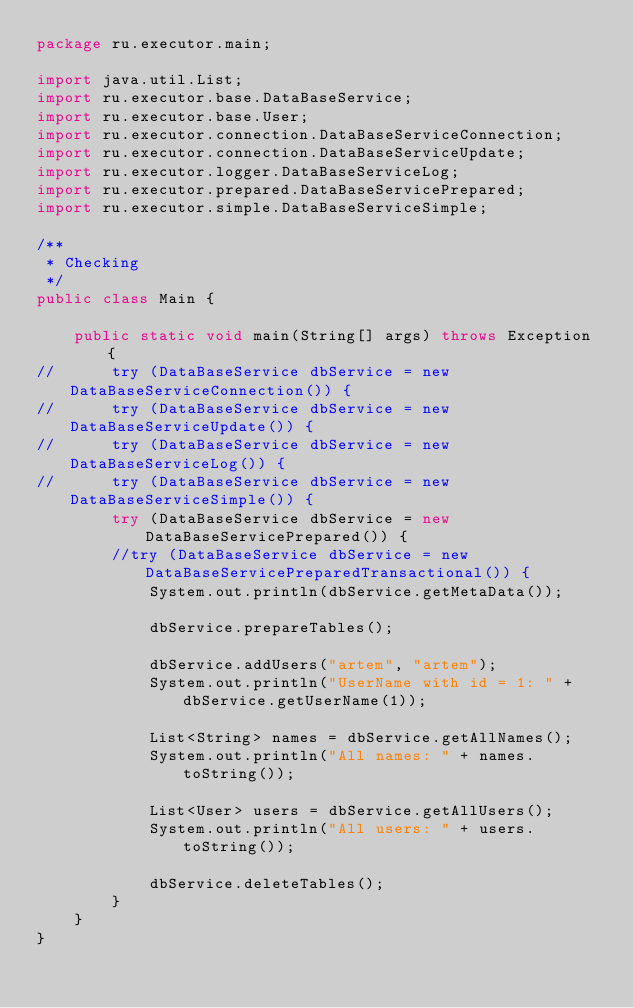Convert code to text. <code><loc_0><loc_0><loc_500><loc_500><_Java_>package ru.executor.main;

import java.util.List;
import ru.executor.base.DataBaseService;
import ru.executor.base.User;
import ru.executor.connection.DataBaseServiceConnection;
import ru.executor.connection.DataBaseServiceUpdate;
import ru.executor.logger.DataBaseServiceLog;
import ru.executor.prepared.DataBaseServicePrepared;
import ru.executor.simple.DataBaseServiceSimple;

/**
 * Checking
 */
public class Main {

    public static void main(String[] args) throws Exception {
//      try (DataBaseService dbService = new DataBaseServiceConnection()) {
//      try (DataBaseService dbService = new DataBaseServiceUpdate()) {
//      try (DataBaseService dbService = new DataBaseServiceLog()) {
//      try (DataBaseService dbService = new DataBaseServiceSimple()) {
        try (DataBaseService dbService = new DataBaseServicePrepared()) {
        //try (DataBaseService dbService = new DataBaseServicePreparedTransactional()) {
            System.out.println(dbService.getMetaData());

            dbService.prepareTables();

            dbService.addUsers("artem", "artem");
            System.out.println("UserName with id = 1: " + dbService.getUserName(1));

            List<String> names = dbService.getAllNames();
            System.out.println("All names: " + names.toString());

            List<User> users = dbService.getAllUsers();
            System.out.println("All users: " + users.toString());

            dbService.deleteTables();
        }
    }
}
</code> 